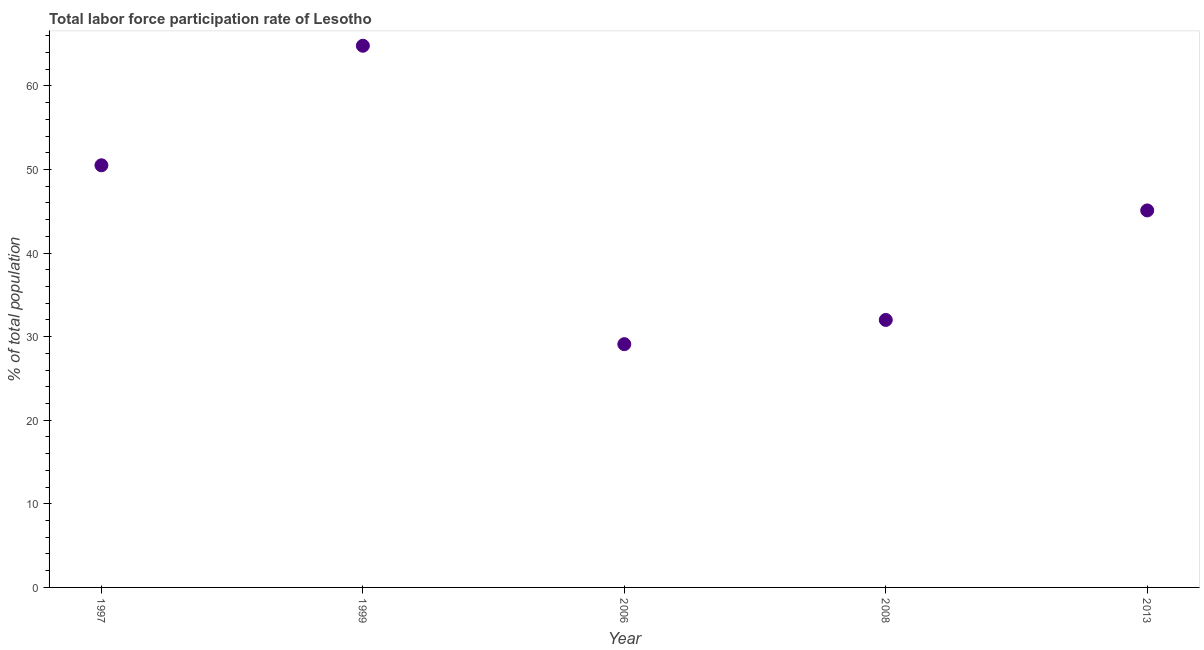What is the total labor force participation rate in 2008?
Provide a succinct answer. 32. Across all years, what is the maximum total labor force participation rate?
Offer a terse response. 64.8. Across all years, what is the minimum total labor force participation rate?
Ensure brevity in your answer.  29.1. In which year was the total labor force participation rate maximum?
Provide a short and direct response. 1999. What is the sum of the total labor force participation rate?
Keep it short and to the point. 221.5. What is the difference between the total labor force participation rate in 2006 and 2008?
Provide a short and direct response. -2.9. What is the average total labor force participation rate per year?
Provide a succinct answer. 44.3. What is the median total labor force participation rate?
Give a very brief answer. 45.1. In how many years, is the total labor force participation rate greater than 12 %?
Offer a terse response. 5. Do a majority of the years between 1997 and 2006 (inclusive) have total labor force participation rate greater than 62 %?
Ensure brevity in your answer.  No. What is the ratio of the total labor force participation rate in 1997 to that in 2013?
Your response must be concise. 1.12. Is the total labor force participation rate in 2006 less than that in 2013?
Provide a succinct answer. Yes. What is the difference between the highest and the second highest total labor force participation rate?
Your answer should be compact. 14.3. What is the difference between the highest and the lowest total labor force participation rate?
Your answer should be compact. 35.7. In how many years, is the total labor force participation rate greater than the average total labor force participation rate taken over all years?
Your answer should be very brief. 3. Does the total labor force participation rate monotonically increase over the years?
Your answer should be compact. No. How many dotlines are there?
Offer a terse response. 1. What is the difference between two consecutive major ticks on the Y-axis?
Give a very brief answer. 10. Does the graph contain any zero values?
Your answer should be compact. No. Does the graph contain grids?
Offer a very short reply. No. What is the title of the graph?
Offer a terse response. Total labor force participation rate of Lesotho. What is the label or title of the X-axis?
Offer a terse response. Year. What is the label or title of the Y-axis?
Your answer should be compact. % of total population. What is the % of total population in 1997?
Provide a short and direct response. 50.5. What is the % of total population in 1999?
Keep it short and to the point. 64.8. What is the % of total population in 2006?
Ensure brevity in your answer.  29.1. What is the % of total population in 2008?
Offer a very short reply. 32. What is the % of total population in 2013?
Offer a terse response. 45.1. What is the difference between the % of total population in 1997 and 1999?
Your answer should be compact. -14.3. What is the difference between the % of total population in 1997 and 2006?
Provide a succinct answer. 21.4. What is the difference between the % of total population in 1997 and 2008?
Offer a very short reply. 18.5. What is the difference between the % of total population in 1999 and 2006?
Make the answer very short. 35.7. What is the difference between the % of total population in 1999 and 2008?
Make the answer very short. 32.8. What is the difference between the % of total population in 1999 and 2013?
Offer a terse response. 19.7. What is the difference between the % of total population in 2006 and 2008?
Keep it short and to the point. -2.9. What is the difference between the % of total population in 2006 and 2013?
Provide a short and direct response. -16. What is the difference between the % of total population in 2008 and 2013?
Make the answer very short. -13.1. What is the ratio of the % of total population in 1997 to that in 1999?
Ensure brevity in your answer.  0.78. What is the ratio of the % of total population in 1997 to that in 2006?
Offer a very short reply. 1.74. What is the ratio of the % of total population in 1997 to that in 2008?
Your answer should be compact. 1.58. What is the ratio of the % of total population in 1997 to that in 2013?
Provide a short and direct response. 1.12. What is the ratio of the % of total population in 1999 to that in 2006?
Your answer should be very brief. 2.23. What is the ratio of the % of total population in 1999 to that in 2008?
Your answer should be very brief. 2.02. What is the ratio of the % of total population in 1999 to that in 2013?
Provide a succinct answer. 1.44. What is the ratio of the % of total population in 2006 to that in 2008?
Make the answer very short. 0.91. What is the ratio of the % of total population in 2006 to that in 2013?
Give a very brief answer. 0.65. What is the ratio of the % of total population in 2008 to that in 2013?
Make the answer very short. 0.71. 